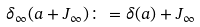Convert formula to latex. <formula><loc_0><loc_0><loc_500><loc_500>\delta _ { \infty } ( a + J _ { \infty } ) \colon = \delta ( a ) + J _ { \infty }</formula> 